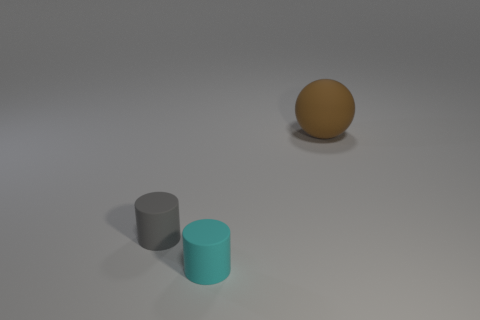Are there an equal number of rubber cylinders that are in front of the small gray rubber object and brown objects?
Ensure brevity in your answer.  Yes. What number of objects are small cyan things or matte things in front of the gray cylinder?
Your response must be concise. 1. Is there another object of the same shape as the small cyan thing?
Your answer should be compact. Yes. What size is the sphere behind the tiny thing behind the tiny rubber thing in front of the tiny gray object?
Keep it short and to the point. Large. Are there the same number of gray cylinders that are behind the gray cylinder and cyan things to the left of the brown ball?
Your answer should be very brief. No. There is a brown sphere that is made of the same material as the small cyan cylinder; what size is it?
Your response must be concise. Large. What is the color of the large object?
Make the answer very short. Brown. How many tiny objects have the same color as the ball?
Offer a very short reply. 0. What is the material of the gray cylinder that is the same size as the cyan matte thing?
Offer a terse response. Rubber. Is there a big rubber sphere that is in front of the small rubber cylinder that is on the left side of the cyan thing?
Offer a terse response. No. 